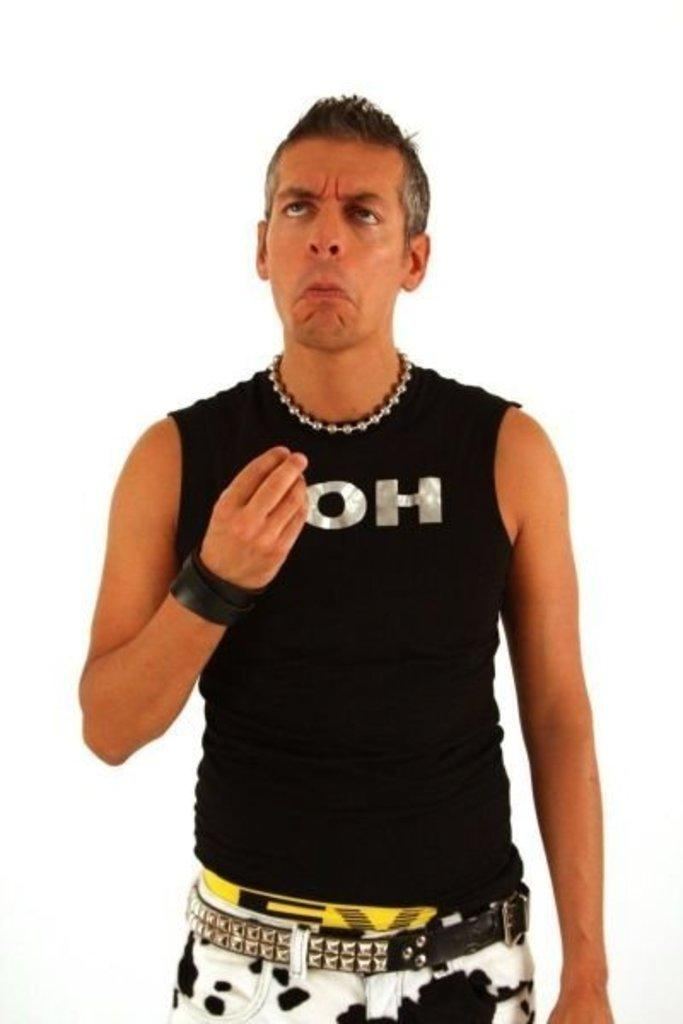Provide a one-sentence caption for the provided image. guy with wierd expression on his face wearing black tank top ith letter OH on it. 